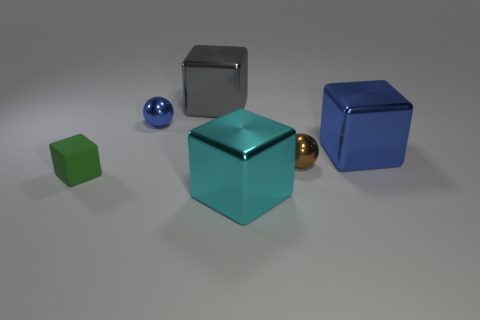There is a big metallic object that is in front of the green matte block that is in front of the brown shiny ball; what number of tiny blue objects are left of it?
Provide a succinct answer. 1. Does the small cube have the same color as the large metal block to the left of the cyan shiny cube?
Your response must be concise. No. What material is the tiny thing that is left of the small metallic ball that is behind the tiny ball in front of the big blue cube?
Give a very brief answer. Rubber. There is a large gray shiny object on the right side of the tiny green object; does it have the same shape as the cyan thing?
Provide a short and direct response. Yes. There is a gray thing behind the small blue shiny thing; what material is it?
Offer a terse response. Metal. There is a tiny sphere that is on the left side of the tiny ball on the right side of the large cyan metallic thing; what is its material?
Provide a succinct answer. Metal. What is the size of the green cube that is left of the large cyan block?
Offer a very short reply. Small. What number of brown objects are either matte things or tiny metal things?
Provide a succinct answer. 1. Is there anything else that has the same material as the tiny cube?
Make the answer very short. No. There is a tiny object that is the same shape as the large cyan object; what is it made of?
Offer a very short reply. Rubber. 